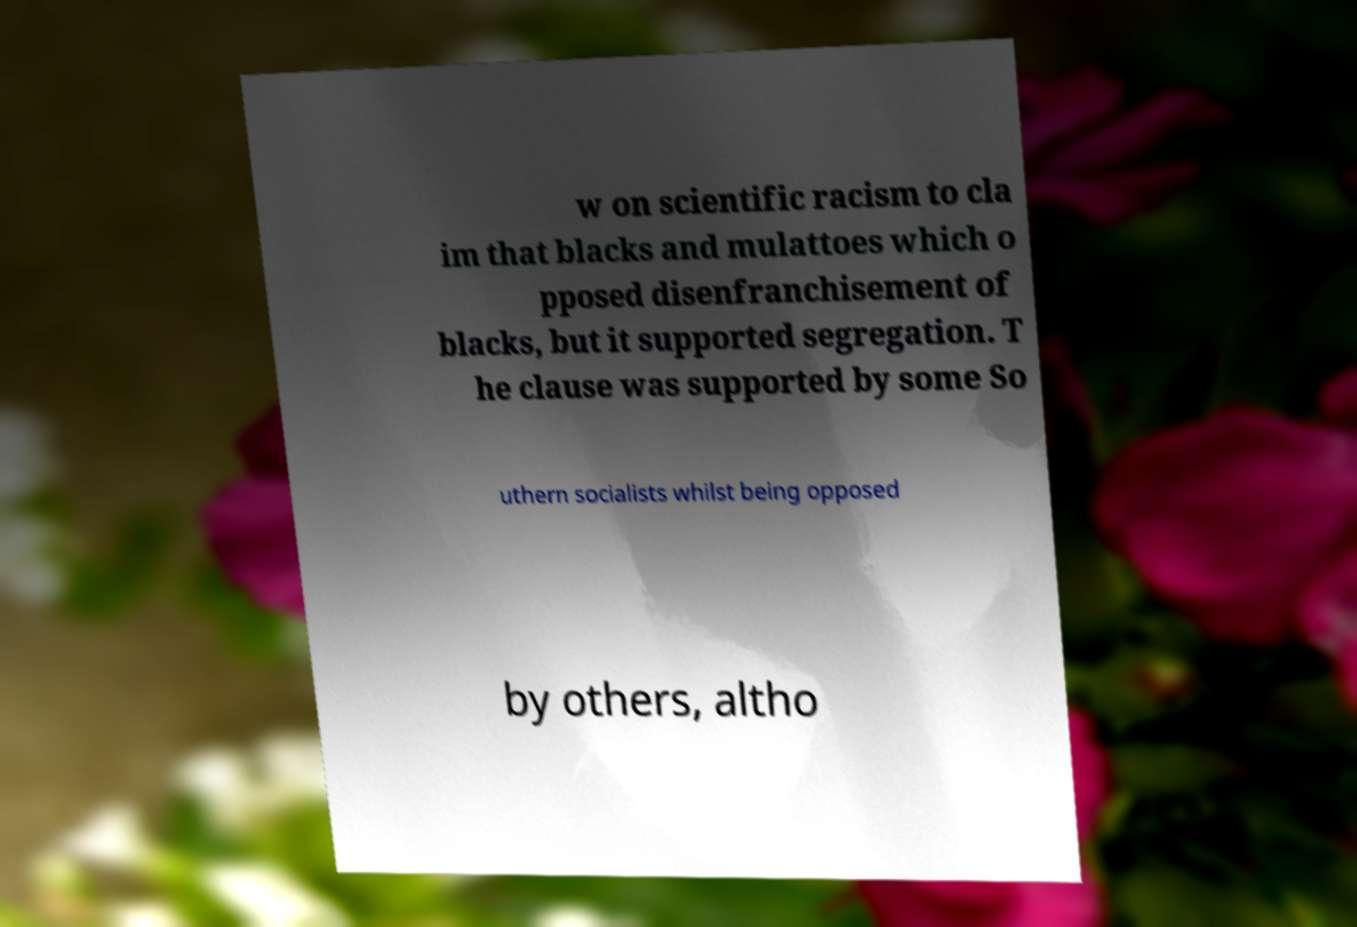For documentation purposes, I need the text within this image transcribed. Could you provide that? w on scientific racism to cla im that blacks and mulattoes which o pposed disenfranchisement of blacks, but it supported segregation. T he clause was supported by some So uthern socialists whilst being opposed by others, altho 